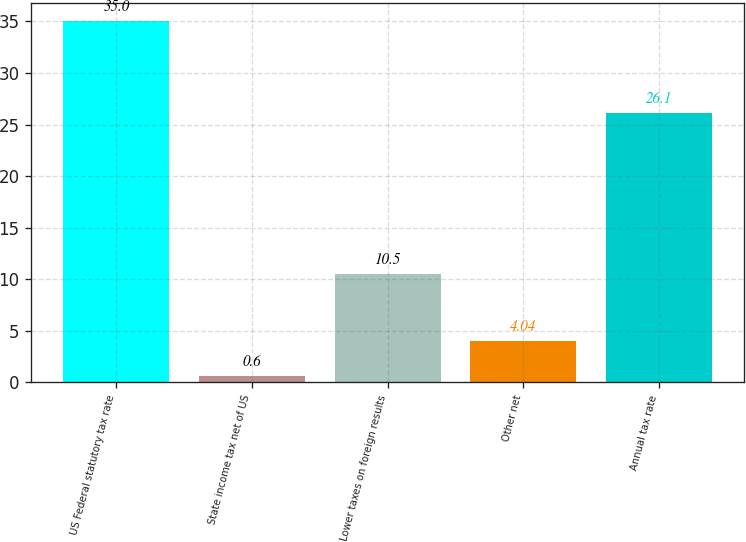Convert chart to OTSL. <chart><loc_0><loc_0><loc_500><loc_500><bar_chart><fcel>US Federal statutory tax rate<fcel>State income tax net of US<fcel>Lower taxes on foreign results<fcel>Other net<fcel>Annual tax rate<nl><fcel>35<fcel>0.6<fcel>10.5<fcel>4.04<fcel>26.1<nl></chart> 